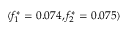Convert formula to latex. <formula><loc_0><loc_0><loc_500><loc_500>( f _ { 1 } ^ { * } = 0 . 0 7 4 , f _ { 2 } ^ { * } = 0 . 0 7 5 )</formula> 